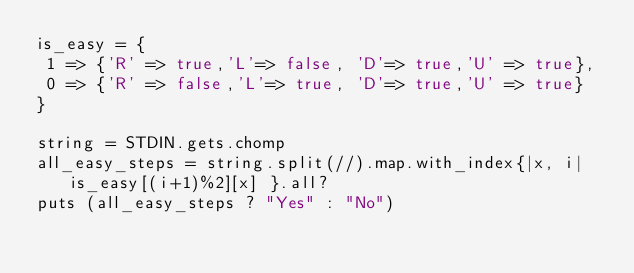Convert code to text. <code><loc_0><loc_0><loc_500><loc_500><_Ruby_>is_easy = {
 1 => {'R' => true,'L'=> false, 'D'=> true,'U' => true},
 0 => {'R' => false,'L'=> true, 'D'=> true,'U' => true}
}

string = STDIN.gets.chomp
all_easy_steps = string.split(//).map.with_index{|x, i| is_easy[(i+1)%2][x] }.all?
puts (all_easy_steps ? "Yes" : "No")
</code> 